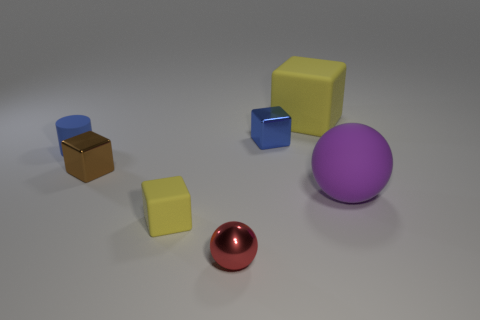What is the shape of the big object that is the same color as the tiny matte block?
Offer a terse response. Cube. Is the shape of the red metallic object the same as the matte thing that is in front of the purple object?
Give a very brief answer. No. There is a big object in front of the yellow matte object behind the tiny cube that is in front of the brown thing; what color is it?
Offer a very short reply. Purple. Is there anything else that has the same material as the purple object?
Provide a short and direct response. Yes. There is a small blue object on the left side of the small red metal object; is its shape the same as the large purple matte thing?
Offer a very short reply. No. What material is the tiny brown object?
Your answer should be very brief. Metal. The large matte object behind the small thing that is behind the small blue object left of the blue metal object is what shape?
Keep it short and to the point. Cube. How many other things are the same shape as the brown thing?
Provide a succinct answer. 3. Is the color of the large rubber cube the same as the rubber block in front of the tiny blue metal cube?
Provide a short and direct response. Yes. What number of brown metallic objects are there?
Provide a short and direct response. 1. 